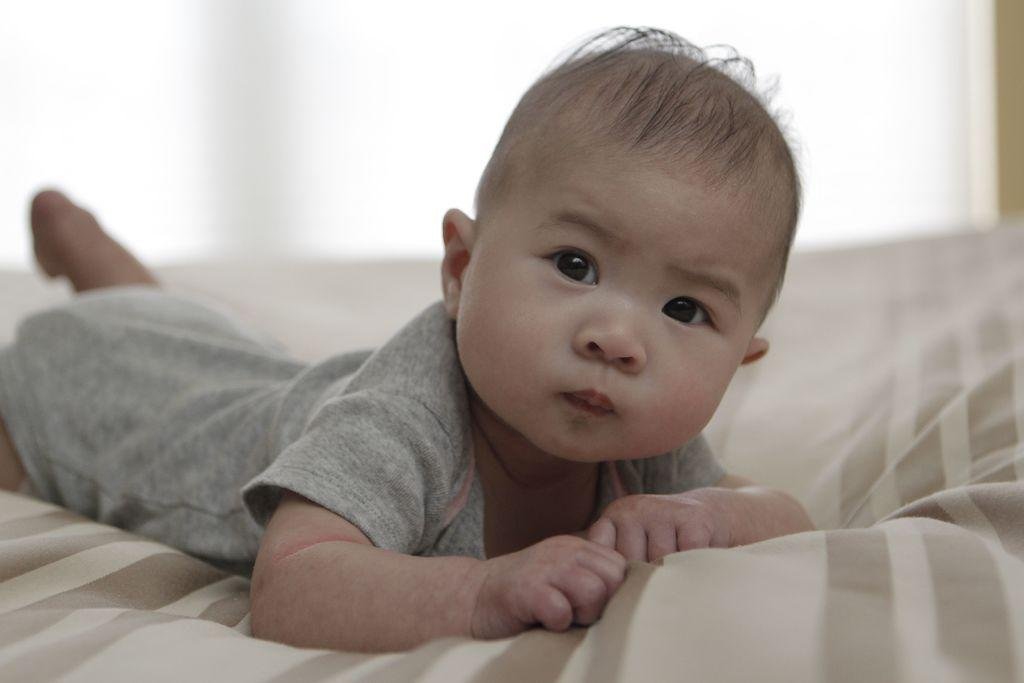What is the main subject of the image? There is a baby in the image. Where is the baby located in the image? The baby is lying on a bed. What type of knowledge does the baby have about trucks in the image? There is no indication in the image that the baby has any knowledge about trucks, as the image only shows a baby lying on a bed. 